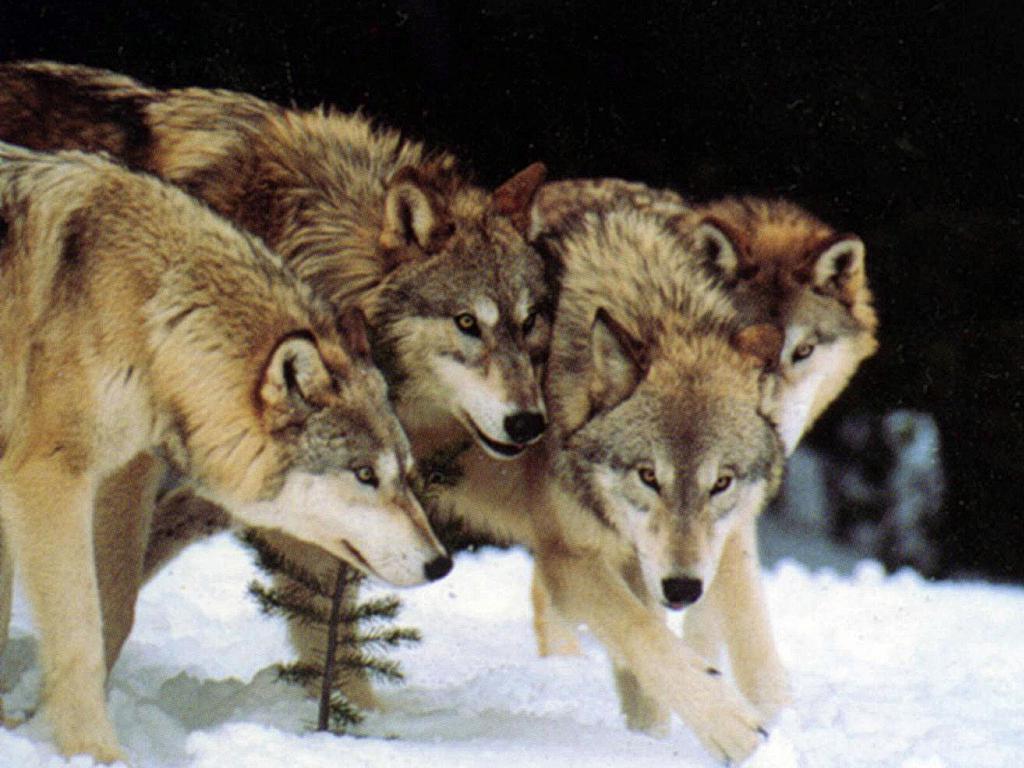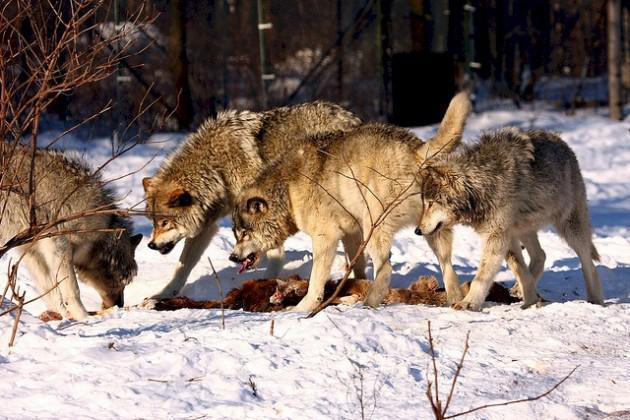The first image is the image on the left, the second image is the image on the right. For the images shown, is this caption "The dogs in the image on the left are in a snowy area." true? Answer yes or no. Yes. 